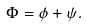Convert formula to latex. <formula><loc_0><loc_0><loc_500><loc_500>\Phi = \phi + \psi .</formula> 